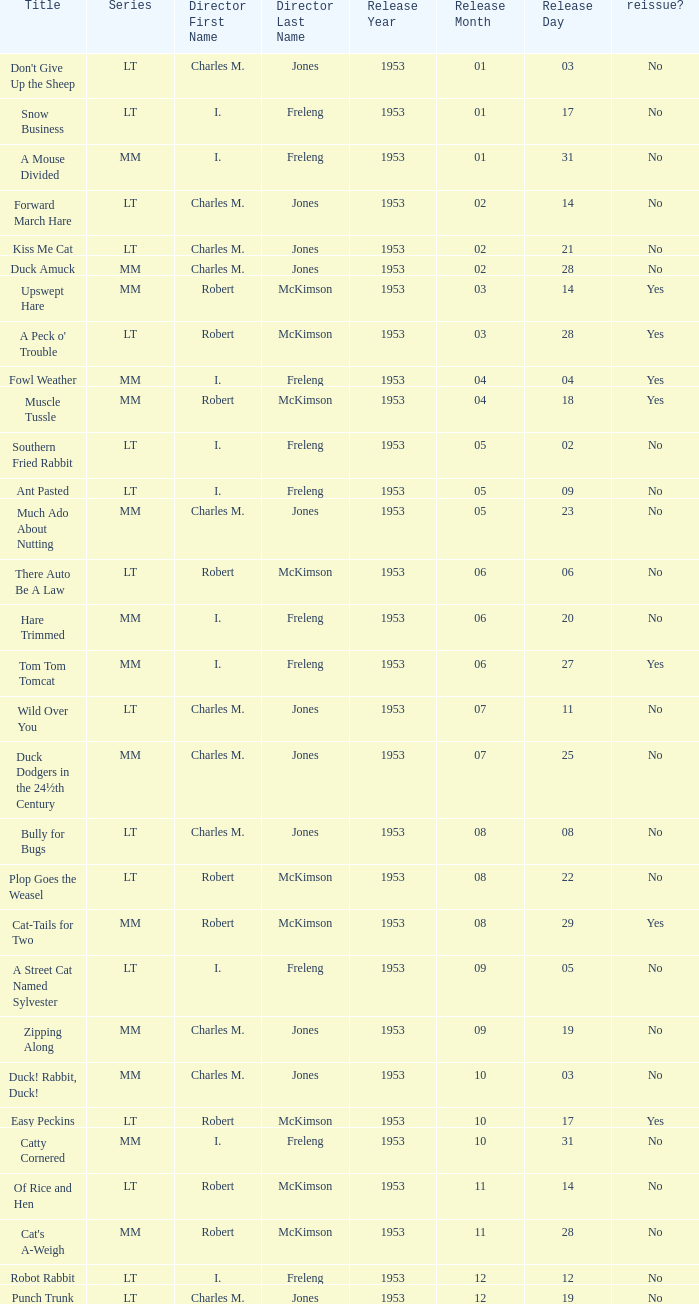What's the title for the release date of 1953-01-31 in the MM series, no reissue, and a director of I. Freleng? A Mouse Divided. 